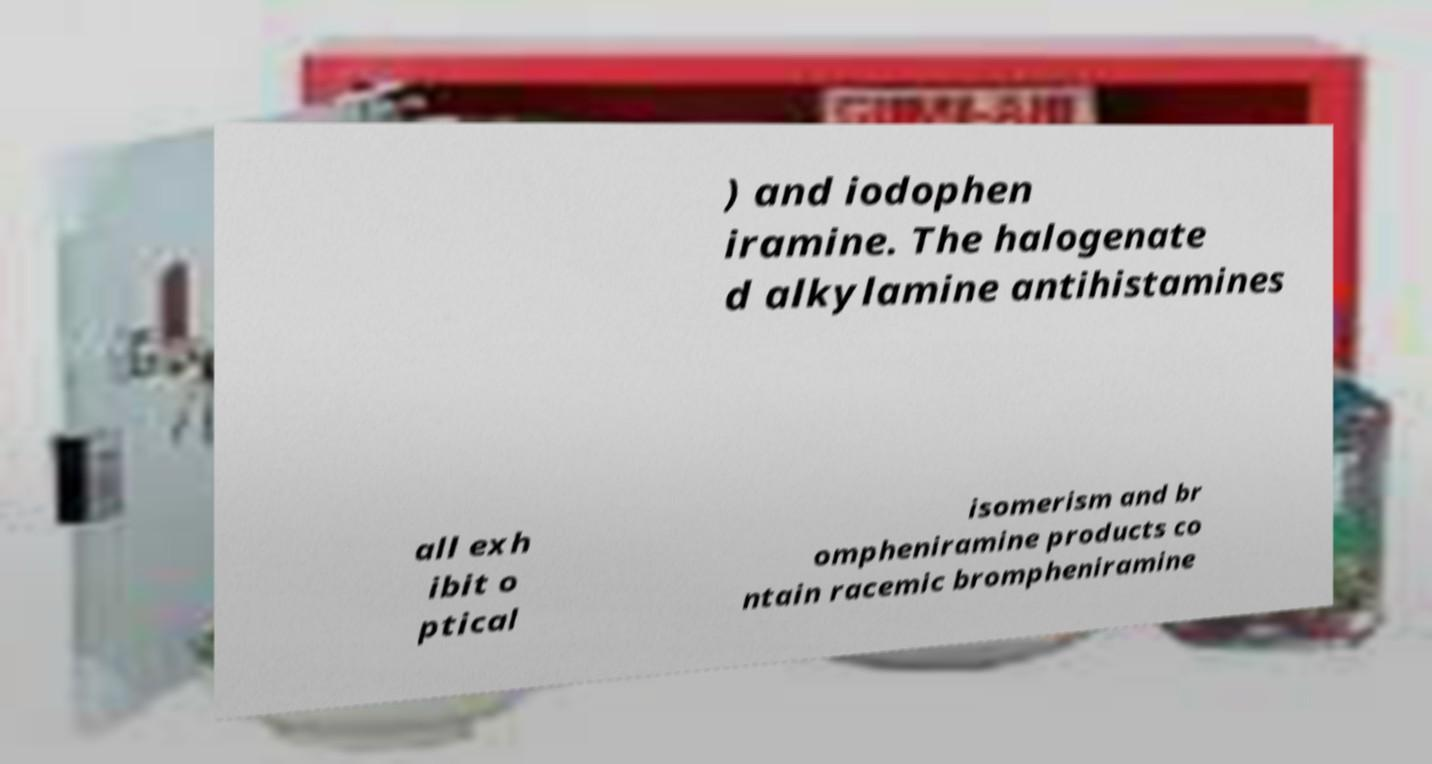I need the written content from this picture converted into text. Can you do that? ) and iodophen iramine. The halogenate d alkylamine antihistamines all exh ibit o ptical isomerism and br ompheniramine products co ntain racemic brompheniramine 